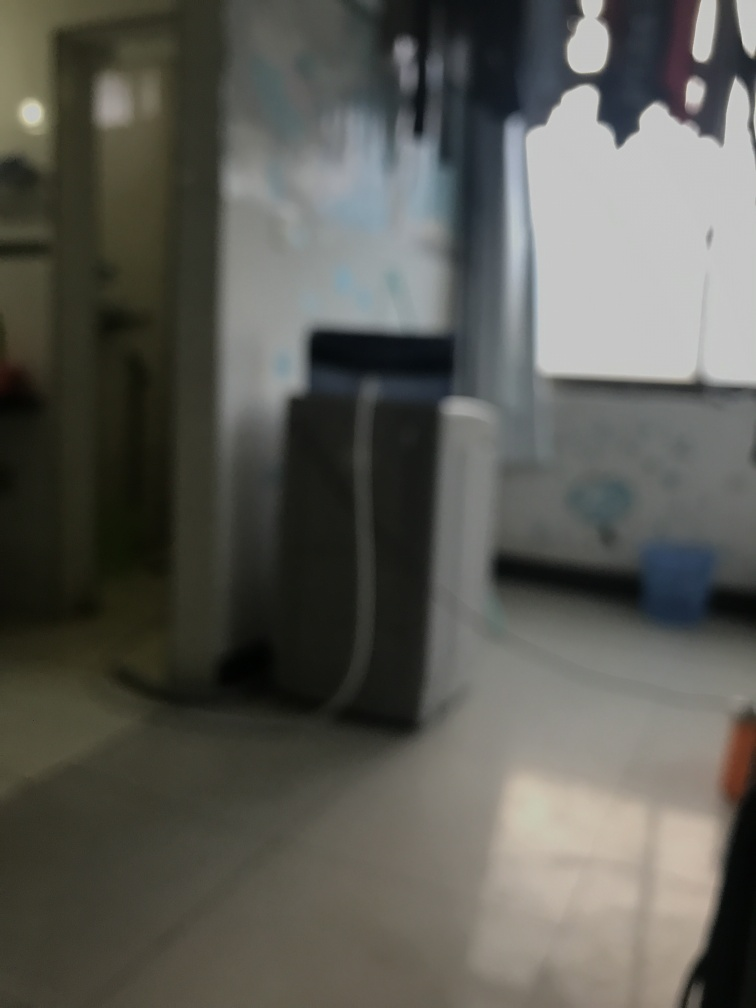Is the entrance blurry?
A. No
B. Yes
Answer with the option's letter from the given choices directly.
 B. 